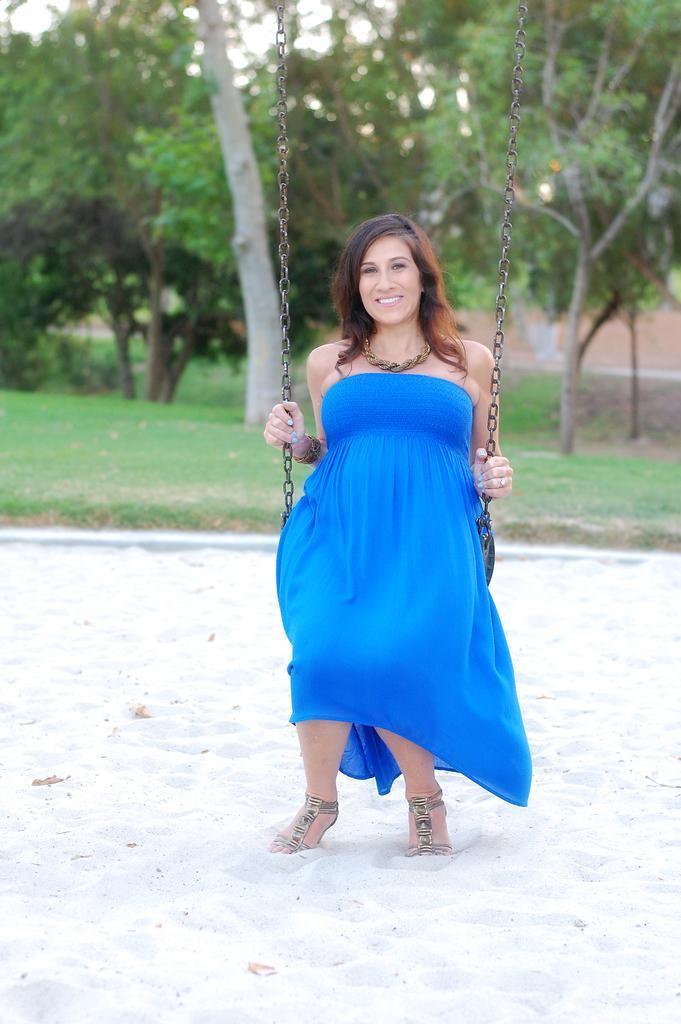Can you describe this image briefly? In this image we can see a women wearing blue dress is sitting on a seat held with chains. In the background we can see group of trees. 